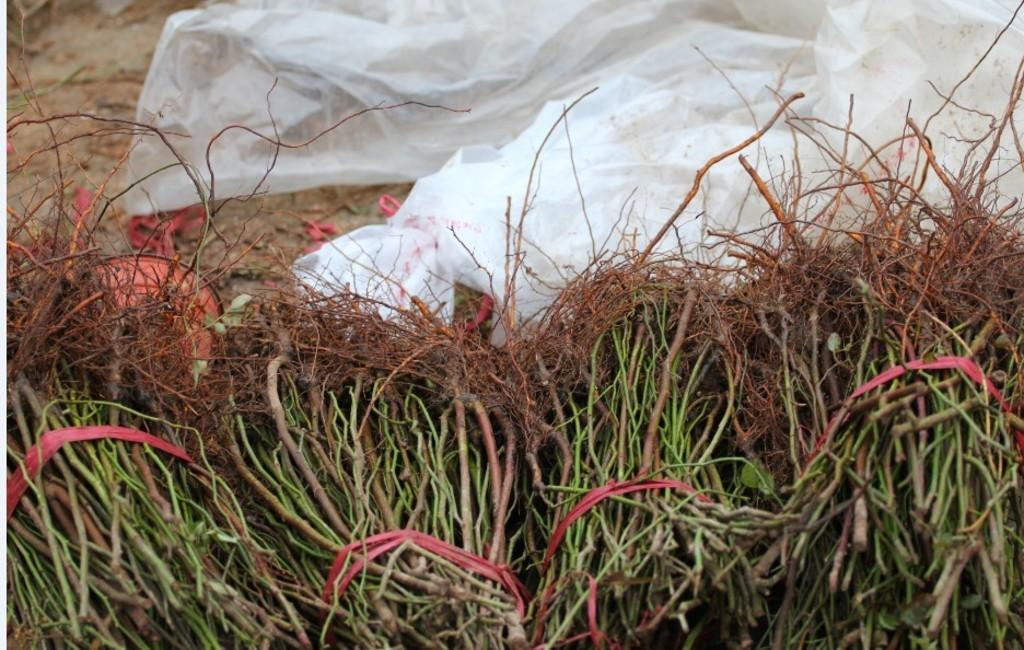Where was the image taken? The image was clicked outside. What can be seen in the foreground of the image? There are stems tied with ropes in the foreground of the image. What is the color of the object lying on the ground in the image? There is a white color object lying on the ground in the image. What type of appliance can be seen in the image? There is no appliance present in the image. How thick is the fog in the image? There is no fog present in the image. 